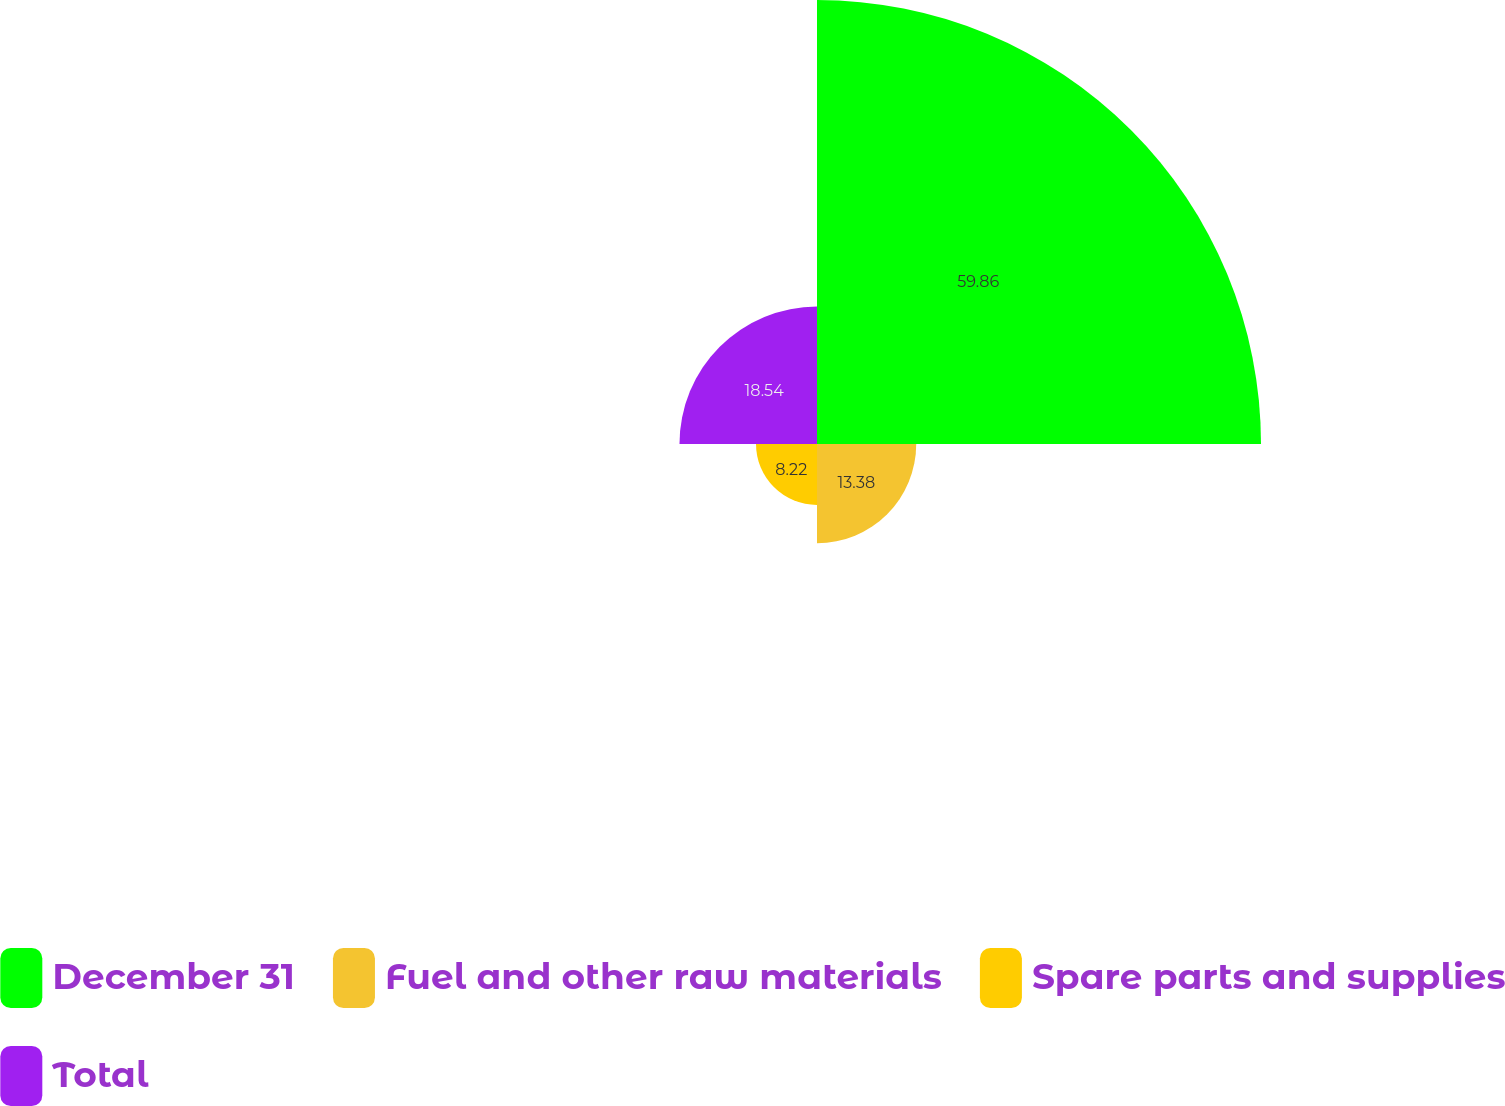<chart> <loc_0><loc_0><loc_500><loc_500><pie_chart><fcel>December 31<fcel>Fuel and other raw materials<fcel>Spare parts and supplies<fcel>Total<nl><fcel>59.86%<fcel>13.38%<fcel>8.22%<fcel>18.54%<nl></chart> 